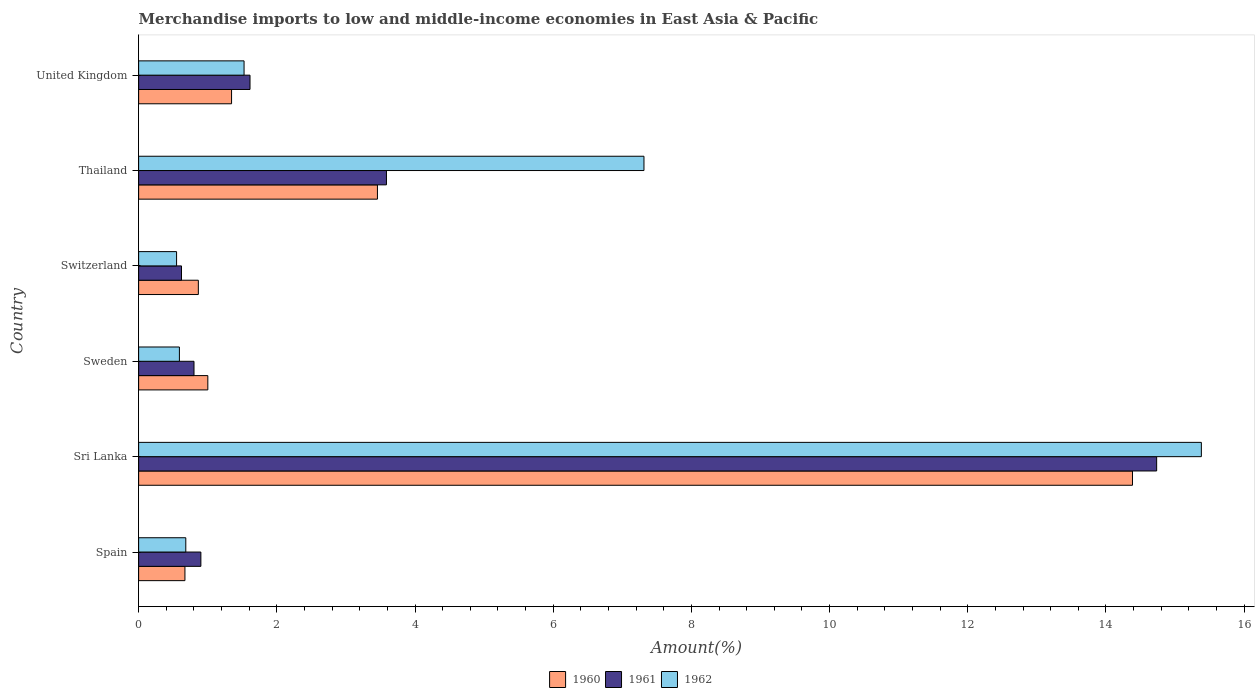Are the number of bars on each tick of the Y-axis equal?
Offer a very short reply. Yes. How many bars are there on the 2nd tick from the top?
Provide a short and direct response. 3. How many bars are there on the 3rd tick from the bottom?
Keep it short and to the point. 3. In how many cases, is the number of bars for a given country not equal to the number of legend labels?
Keep it short and to the point. 0. What is the percentage of amount earned from merchandise imports in 1960 in Thailand?
Ensure brevity in your answer.  3.46. Across all countries, what is the maximum percentage of amount earned from merchandise imports in 1961?
Keep it short and to the point. 14.73. Across all countries, what is the minimum percentage of amount earned from merchandise imports in 1960?
Your response must be concise. 0.67. In which country was the percentage of amount earned from merchandise imports in 1960 maximum?
Ensure brevity in your answer.  Sri Lanka. In which country was the percentage of amount earned from merchandise imports in 1961 minimum?
Your response must be concise. Switzerland. What is the total percentage of amount earned from merchandise imports in 1961 in the graph?
Your answer should be compact. 22.25. What is the difference between the percentage of amount earned from merchandise imports in 1962 in Sri Lanka and that in Sweden?
Your response must be concise. 14.79. What is the difference between the percentage of amount earned from merchandise imports in 1961 in United Kingdom and the percentage of amount earned from merchandise imports in 1960 in Sweden?
Your response must be concise. 0.61. What is the average percentage of amount earned from merchandise imports in 1961 per country?
Your answer should be compact. 3.71. What is the difference between the percentage of amount earned from merchandise imports in 1961 and percentage of amount earned from merchandise imports in 1962 in United Kingdom?
Your response must be concise. 0.09. In how many countries, is the percentage of amount earned from merchandise imports in 1960 greater than 1.6 %?
Your answer should be very brief. 2. What is the ratio of the percentage of amount earned from merchandise imports in 1960 in Sweden to that in Thailand?
Give a very brief answer. 0.29. What is the difference between the highest and the second highest percentage of amount earned from merchandise imports in 1962?
Make the answer very short. 8.07. What is the difference between the highest and the lowest percentage of amount earned from merchandise imports in 1961?
Offer a very short reply. 14.11. Is the sum of the percentage of amount earned from merchandise imports in 1961 in Sri Lanka and Switzerland greater than the maximum percentage of amount earned from merchandise imports in 1962 across all countries?
Your response must be concise. No. What does the 3rd bar from the bottom in Switzerland represents?
Provide a short and direct response. 1962. Is it the case that in every country, the sum of the percentage of amount earned from merchandise imports in 1961 and percentage of amount earned from merchandise imports in 1962 is greater than the percentage of amount earned from merchandise imports in 1960?
Your answer should be compact. Yes. How many bars are there?
Keep it short and to the point. 18. Does the graph contain grids?
Your answer should be very brief. No. How many legend labels are there?
Provide a short and direct response. 3. What is the title of the graph?
Provide a short and direct response. Merchandise imports to low and middle-income economies in East Asia & Pacific. What is the label or title of the X-axis?
Offer a very short reply. Amount(%). What is the Amount(%) in 1960 in Spain?
Give a very brief answer. 0.67. What is the Amount(%) in 1961 in Spain?
Keep it short and to the point. 0.9. What is the Amount(%) of 1962 in Spain?
Provide a short and direct response. 0.68. What is the Amount(%) in 1960 in Sri Lanka?
Keep it short and to the point. 14.38. What is the Amount(%) of 1961 in Sri Lanka?
Keep it short and to the point. 14.73. What is the Amount(%) in 1962 in Sri Lanka?
Give a very brief answer. 15.38. What is the Amount(%) of 1960 in Sweden?
Your answer should be compact. 1. What is the Amount(%) of 1961 in Sweden?
Offer a very short reply. 0.8. What is the Amount(%) in 1962 in Sweden?
Keep it short and to the point. 0.59. What is the Amount(%) in 1960 in Switzerland?
Keep it short and to the point. 0.86. What is the Amount(%) of 1961 in Switzerland?
Keep it short and to the point. 0.62. What is the Amount(%) of 1962 in Switzerland?
Offer a very short reply. 0.55. What is the Amount(%) of 1960 in Thailand?
Your answer should be compact. 3.46. What is the Amount(%) in 1961 in Thailand?
Keep it short and to the point. 3.59. What is the Amount(%) in 1962 in Thailand?
Provide a succinct answer. 7.31. What is the Amount(%) of 1960 in United Kingdom?
Keep it short and to the point. 1.34. What is the Amount(%) of 1961 in United Kingdom?
Offer a very short reply. 1.61. What is the Amount(%) in 1962 in United Kingdom?
Provide a short and direct response. 1.53. Across all countries, what is the maximum Amount(%) in 1960?
Your response must be concise. 14.38. Across all countries, what is the maximum Amount(%) of 1961?
Your answer should be compact. 14.73. Across all countries, what is the maximum Amount(%) of 1962?
Your answer should be very brief. 15.38. Across all countries, what is the minimum Amount(%) of 1960?
Offer a very short reply. 0.67. Across all countries, what is the minimum Amount(%) in 1961?
Offer a very short reply. 0.62. Across all countries, what is the minimum Amount(%) in 1962?
Ensure brevity in your answer.  0.55. What is the total Amount(%) in 1960 in the graph?
Your answer should be compact. 21.72. What is the total Amount(%) in 1961 in the graph?
Make the answer very short. 22.25. What is the total Amount(%) of 1962 in the graph?
Make the answer very short. 26.04. What is the difference between the Amount(%) of 1960 in Spain and that in Sri Lanka?
Provide a succinct answer. -13.71. What is the difference between the Amount(%) of 1961 in Spain and that in Sri Lanka?
Provide a short and direct response. -13.83. What is the difference between the Amount(%) in 1962 in Spain and that in Sri Lanka?
Your answer should be compact. -14.7. What is the difference between the Amount(%) of 1960 in Spain and that in Sweden?
Your answer should be compact. -0.33. What is the difference between the Amount(%) of 1961 in Spain and that in Sweden?
Your answer should be compact. 0.1. What is the difference between the Amount(%) in 1962 in Spain and that in Sweden?
Offer a terse response. 0.09. What is the difference between the Amount(%) in 1960 in Spain and that in Switzerland?
Give a very brief answer. -0.19. What is the difference between the Amount(%) in 1961 in Spain and that in Switzerland?
Your response must be concise. 0.28. What is the difference between the Amount(%) in 1962 in Spain and that in Switzerland?
Ensure brevity in your answer.  0.13. What is the difference between the Amount(%) in 1960 in Spain and that in Thailand?
Keep it short and to the point. -2.79. What is the difference between the Amount(%) of 1961 in Spain and that in Thailand?
Your answer should be very brief. -2.69. What is the difference between the Amount(%) of 1962 in Spain and that in Thailand?
Offer a very short reply. -6.63. What is the difference between the Amount(%) of 1960 in Spain and that in United Kingdom?
Your answer should be compact. -0.67. What is the difference between the Amount(%) in 1961 in Spain and that in United Kingdom?
Offer a terse response. -0.71. What is the difference between the Amount(%) of 1962 in Spain and that in United Kingdom?
Provide a succinct answer. -0.84. What is the difference between the Amount(%) in 1960 in Sri Lanka and that in Sweden?
Keep it short and to the point. 13.38. What is the difference between the Amount(%) of 1961 in Sri Lanka and that in Sweden?
Your answer should be compact. 13.93. What is the difference between the Amount(%) in 1962 in Sri Lanka and that in Sweden?
Provide a succinct answer. 14.79. What is the difference between the Amount(%) in 1960 in Sri Lanka and that in Switzerland?
Offer a very short reply. 13.52. What is the difference between the Amount(%) in 1961 in Sri Lanka and that in Switzerland?
Provide a short and direct response. 14.11. What is the difference between the Amount(%) of 1962 in Sri Lanka and that in Switzerland?
Your answer should be very brief. 14.83. What is the difference between the Amount(%) of 1960 in Sri Lanka and that in Thailand?
Offer a terse response. 10.93. What is the difference between the Amount(%) of 1961 in Sri Lanka and that in Thailand?
Offer a very short reply. 11.15. What is the difference between the Amount(%) in 1962 in Sri Lanka and that in Thailand?
Your answer should be compact. 8.07. What is the difference between the Amount(%) of 1960 in Sri Lanka and that in United Kingdom?
Give a very brief answer. 13.04. What is the difference between the Amount(%) of 1961 in Sri Lanka and that in United Kingdom?
Your answer should be compact. 13.12. What is the difference between the Amount(%) in 1962 in Sri Lanka and that in United Kingdom?
Offer a very short reply. 13.85. What is the difference between the Amount(%) in 1960 in Sweden and that in Switzerland?
Your response must be concise. 0.14. What is the difference between the Amount(%) of 1961 in Sweden and that in Switzerland?
Your response must be concise. 0.18. What is the difference between the Amount(%) of 1962 in Sweden and that in Switzerland?
Your answer should be very brief. 0.04. What is the difference between the Amount(%) of 1960 in Sweden and that in Thailand?
Make the answer very short. -2.45. What is the difference between the Amount(%) in 1961 in Sweden and that in Thailand?
Offer a terse response. -2.79. What is the difference between the Amount(%) of 1962 in Sweden and that in Thailand?
Make the answer very short. -6.72. What is the difference between the Amount(%) of 1960 in Sweden and that in United Kingdom?
Ensure brevity in your answer.  -0.34. What is the difference between the Amount(%) in 1961 in Sweden and that in United Kingdom?
Give a very brief answer. -0.81. What is the difference between the Amount(%) of 1962 in Sweden and that in United Kingdom?
Your response must be concise. -0.94. What is the difference between the Amount(%) in 1960 in Switzerland and that in Thailand?
Give a very brief answer. -2.59. What is the difference between the Amount(%) of 1961 in Switzerland and that in Thailand?
Ensure brevity in your answer.  -2.97. What is the difference between the Amount(%) of 1962 in Switzerland and that in Thailand?
Make the answer very short. -6.76. What is the difference between the Amount(%) in 1960 in Switzerland and that in United Kingdom?
Offer a very short reply. -0.48. What is the difference between the Amount(%) of 1961 in Switzerland and that in United Kingdom?
Provide a short and direct response. -0.99. What is the difference between the Amount(%) of 1962 in Switzerland and that in United Kingdom?
Provide a succinct answer. -0.98. What is the difference between the Amount(%) in 1960 in Thailand and that in United Kingdom?
Keep it short and to the point. 2.11. What is the difference between the Amount(%) of 1961 in Thailand and that in United Kingdom?
Provide a short and direct response. 1.97. What is the difference between the Amount(%) in 1962 in Thailand and that in United Kingdom?
Keep it short and to the point. 5.79. What is the difference between the Amount(%) of 1960 in Spain and the Amount(%) of 1961 in Sri Lanka?
Provide a short and direct response. -14.06. What is the difference between the Amount(%) in 1960 in Spain and the Amount(%) in 1962 in Sri Lanka?
Keep it short and to the point. -14.71. What is the difference between the Amount(%) of 1961 in Spain and the Amount(%) of 1962 in Sri Lanka?
Your answer should be very brief. -14.48. What is the difference between the Amount(%) in 1960 in Spain and the Amount(%) in 1961 in Sweden?
Your answer should be very brief. -0.13. What is the difference between the Amount(%) in 1960 in Spain and the Amount(%) in 1962 in Sweden?
Your answer should be very brief. 0.08. What is the difference between the Amount(%) in 1961 in Spain and the Amount(%) in 1962 in Sweden?
Keep it short and to the point. 0.31. What is the difference between the Amount(%) of 1960 in Spain and the Amount(%) of 1961 in Switzerland?
Provide a short and direct response. 0.05. What is the difference between the Amount(%) of 1960 in Spain and the Amount(%) of 1962 in Switzerland?
Keep it short and to the point. 0.12. What is the difference between the Amount(%) of 1961 in Spain and the Amount(%) of 1962 in Switzerland?
Give a very brief answer. 0.35. What is the difference between the Amount(%) of 1960 in Spain and the Amount(%) of 1961 in Thailand?
Your response must be concise. -2.92. What is the difference between the Amount(%) of 1960 in Spain and the Amount(%) of 1962 in Thailand?
Keep it short and to the point. -6.64. What is the difference between the Amount(%) in 1961 in Spain and the Amount(%) in 1962 in Thailand?
Your answer should be compact. -6.41. What is the difference between the Amount(%) in 1960 in Spain and the Amount(%) in 1961 in United Kingdom?
Provide a short and direct response. -0.94. What is the difference between the Amount(%) in 1960 in Spain and the Amount(%) in 1962 in United Kingdom?
Offer a terse response. -0.86. What is the difference between the Amount(%) in 1961 in Spain and the Amount(%) in 1962 in United Kingdom?
Ensure brevity in your answer.  -0.63. What is the difference between the Amount(%) in 1960 in Sri Lanka and the Amount(%) in 1961 in Sweden?
Keep it short and to the point. 13.58. What is the difference between the Amount(%) in 1960 in Sri Lanka and the Amount(%) in 1962 in Sweden?
Give a very brief answer. 13.79. What is the difference between the Amount(%) in 1961 in Sri Lanka and the Amount(%) in 1962 in Sweden?
Keep it short and to the point. 14.14. What is the difference between the Amount(%) of 1960 in Sri Lanka and the Amount(%) of 1961 in Switzerland?
Provide a succinct answer. 13.76. What is the difference between the Amount(%) in 1960 in Sri Lanka and the Amount(%) in 1962 in Switzerland?
Your response must be concise. 13.83. What is the difference between the Amount(%) in 1961 in Sri Lanka and the Amount(%) in 1962 in Switzerland?
Your response must be concise. 14.18. What is the difference between the Amount(%) in 1960 in Sri Lanka and the Amount(%) in 1961 in Thailand?
Make the answer very short. 10.8. What is the difference between the Amount(%) in 1960 in Sri Lanka and the Amount(%) in 1962 in Thailand?
Keep it short and to the point. 7.07. What is the difference between the Amount(%) in 1961 in Sri Lanka and the Amount(%) in 1962 in Thailand?
Ensure brevity in your answer.  7.42. What is the difference between the Amount(%) in 1960 in Sri Lanka and the Amount(%) in 1961 in United Kingdom?
Offer a terse response. 12.77. What is the difference between the Amount(%) of 1960 in Sri Lanka and the Amount(%) of 1962 in United Kingdom?
Your answer should be very brief. 12.86. What is the difference between the Amount(%) in 1961 in Sri Lanka and the Amount(%) in 1962 in United Kingdom?
Provide a succinct answer. 13.21. What is the difference between the Amount(%) in 1960 in Sweden and the Amount(%) in 1961 in Switzerland?
Your answer should be compact. 0.38. What is the difference between the Amount(%) in 1960 in Sweden and the Amount(%) in 1962 in Switzerland?
Make the answer very short. 0.45. What is the difference between the Amount(%) in 1961 in Sweden and the Amount(%) in 1962 in Switzerland?
Your response must be concise. 0.25. What is the difference between the Amount(%) of 1960 in Sweden and the Amount(%) of 1961 in Thailand?
Make the answer very short. -2.59. What is the difference between the Amount(%) of 1960 in Sweden and the Amount(%) of 1962 in Thailand?
Keep it short and to the point. -6.31. What is the difference between the Amount(%) in 1961 in Sweden and the Amount(%) in 1962 in Thailand?
Your answer should be compact. -6.51. What is the difference between the Amount(%) of 1960 in Sweden and the Amount(%) of 1961 in United Kingdom?
Offer a very short reply. -0.61. What is the difference between the Amount(%) of 1960 in Sweden and the Amount(%) of 1962 in United Kingdom?
Give a very brief answer. -0.52. What is the difference between the Amount(%) in 1961 in Sweden and the Amount(%) in 1962 in United Kingdom?
Your response must be concise. -0.72. What is the difference between the Amount(%) of 1960 in Switzerland and the Amount(%) of 1961 in Thailand?
Provide a succinct answer. -2.72. What is the difference between the Amount(%) of 1960 in Switzerland and the Amount(%) of 1962 in Thailand?
Offer a terse response. -6.45. What is the difference between the Amount(%) in 1961 in Switzerland and the Amount(%) in 1962 in Thailand?
Your answer should be compact. -6.69. What is the difference between the Amount(%) of 1960 in Switzerland and the Amount(%) of 1961 in United Kingdom?
Offer a terse response. -0.75. What is the difference between the Amount(%) of 1960 in Switzerland and the Amount(%) of 1962 in United Kingdom?
Your answer should be compact. -0.66. What is the difference between the Amount(%) in 1961 in Switzerland and the Amount(%) in 1962 in United Kingdom?
Make the answer very short. -0.91. What is the difference between the Amount(%) of 1960 in Thailand and the Amount(%) of 1961 in United Kingdom?
Offer a very short reply. 1.84. What is the difference between the Amount(%) of 1960 in Thailand and the Amount(%) of 1962 in United Kingdom?
Offer a very short reply. 1.93. What is the difference between the Amount(%) of 1961 in Thailand and the Amount(%) of 1962 in United Kingdom?
Offer a very short reply. 2.06. What is the average Amount(%) of 1960 per country?
Offer a very short reply. 3.62. What is the average Amount(%) in 1961 per country?
Give a very brief answer. 3.71. What is the average Amount(%) of 1962 per country?
Make the answer very short. 4.34. What is the difference between the Amount(%) of 1960 and Amount(%) of 1961 in Spain?
Offer a very short reply. -0.23. What is the difference between the Amount(%) of 1960 and Amount(%) of 1962 in Spain?
Offer a terse response. -0.01. What is the difference between the Amount(%) in 1961 and Amount(%) in 1962 in Spain?
Ensure brevity in your answer.  0.22. What is the difference between the Amount(%) in 1960 and Amount(%) in 1961 in Sri Lanka?
Keep it short and to the point. -0.35. What is the difference between the Amount(%) in 1960 and Amount(%) in 1962 in Sri Lanka?
Your answer should be compact. -1. What is the difference between the Amount(%) of 1961 and Amount(%) of 1962 in Sri Lanka?
Offer a very short reply. -0.65. What is the difference between the Amount(%) of 1960 and Amount(%) of 1961 in Sweden?
Provide a short and direct response. 0.2. What is the difference between the Amount(%) of 1960 and Amount(%) of 1962 in Sweden?
Give a very brief answer. 0.41. What is the difference between the Amount(%) of 1961 and Amount(%) of 1962 in Sweden?
Make the answer very short. 0.21. What is the difference between the Amount(%) of 1960 and Amount(%) of 1961 in Switzerland?
Your response must be concise. 0.24. What is the difference between the Amount(%) in 1960 and Amount(%) in 1962 in Switzerland?
Your response must be concise. 0.31. What is the difference between the Amount(%) of 1961 and Amount(%) of 1962 in Switzerland?
Make the answer very short. 0.07. What is the difference between the Amount(%) in 1960 and Amount(%) in 1961 in Thailand?
Your answer should be very brief. -0.13. What is the difference between the Amount(%) in 1960 and Amount(%) in 1962 in Thailand?
Keep it short and to the point. -3.86. What is the difference between the Amount(%) of 1961 and Amount(%) of 1962 in Thailand?
Your response must be concise. -3.73. What is the difference between the Amount(%) in 1960 and Amount(%) in 1961 in United Kingdom?
Your answer should be compact. -0.27. What is the difference between the Amount(%) of 1960 and Amount(%) of 1962 in United Kingdom?
Ensure brevity in your answer.  -0.18. What is the difference between the Amount(%) in 1961 and Amount(%) in 1962 in United Kingdom?
Ensure brevity in your answer.  0.09. What is the ratio of the Amount(%) of 1960 in Spain to that in Sri Lanka?
Your response must be concise. 0.05. What is the ratio of the Amount(%) in 1961 in Spain to that in Sri Lanka?
Keep it short and to the point. 0.06. What is the ratio of the Amount(%) of 1962 in Spain to that in Sri Lanka?
Keep it short and to the point. 0.04. What is the ratio of the Amount(%) of 1960 in Spain to that in Sweden?
Ensure brevity in your answer.  0.67. What is the ratio of the Amount(%) in 1961 in Spain to that in Sweden?
Offer a terse response. 1.12. What is the ratio of the Amount(%) in 1962 in Spain to that in Sweden?
Ensure brevity in your answer.  1.16. What is the ratio of the Amount(%) in 1960 in Spain to that in Switzerland?
Give a very brief answer. 0.78. What is the ratio of the Amount(%) of 1961 in Spain to that in Switzerland?
Your response must be concise. 1.45. What is the ratio of the Amount(%) of 1962 in Spain to that in Switzerland?
Your answer should be very brief. 1.24. What is the ratio of the Amount(%) of 1960 in Spain to that in Thailand?
Ensure brevity in your answer.  0.19. What is the ratio of the Amount(%) in 1961 in Spain to that in Thailand?
Your answer should be very brief. 0.25. What is the ratio of the Amount(%) of 1962 in Spain to that in Thailand?
Make the answer very short. 0.09. What is the ratio of the Amount(%) in 1960 in Spain to that in United Kingdom?
Provide a succinct answer. 0.5. What is the ratio of the Amount(%) of 1961 in Spain to that in United Kingdom?
Offer a terse response. 0.56. What is the ratio of the Amount(%) in 1962 in Spain to that in United Kingdom?
Your response must be concise. 0.45. What is the ratio of the Amount(%) of 1960 in Sri Lanka to that in Sweden?
Your answer should be very brief. 14.36. What is the ratio of the Amount(%) in 1961 in Sri Lanka to that in Sweden?
Provide a short and direct response. 18.38. What is the ratio of the Amount(%) of 1962 in Sri Lanka to that in Sweden?
Provide a short and direct response. 26.07. What is the ratio of the Amount(%) of 1960 in Sri Lanka to that in Switzerland?
Offer a very short reply. 16.64. What is the ratio of the Amount(%) in 1961 in Sri Lanka to that in Switzerland?
Ensure brevity in your answer.  23.74. What is the ratio of the Amount(%) in 1962 in Sri Lanka to that in Switzerland?
Provide a short and direct response. 28. What is the ratio of the Amount(%) in 1960 in Sri Lanka to that in Thailand?
Ensure brevity in your answer.  4.16. What is the ratio of the Amount(%) of 1961 in Sri Lanka to that in Thailand?
Offer a terse response. 4.11. What is the ratio of the Amount(%) of 1962 in Sri Lanka to that in Thailand?
Offer a very short reply. 2.1. What is the ratio of the Amount(%) of 1960 in Sri Lanka to that in United Kingdom?
Provide a short and direct response. 10.69. What is the ratio of the Amount(%) of 1961 in Sri Lanka to that in United Kingdom?
Your response must be concise. 9.14. What is the ratio of the Amount(%) of 1962 in Sri Lanka to that in United Kingdom?
Make the answer very short. 10.08. What is the ratio of the Amount(%) in 1960 in Sweden to that in Switzerland?
Give a very brief answer. 1.16. What is the ratio of the Amount(%) in 1961 in Sweden to that in Switzerland?
Provide a short and direct response. 1.29. What is the ratio of the Amount(%) in 1962 in Sweden to that in Switzerland?
Offer a terse response. 1.07. What is the ratio of the Amount(%) of 1960 in Sweden to that in Thailand?
Your response must be concise. 0.29. What is the ratio of the Amount(%) of 1961 in Sweden to that in Thailand?
Make the answer very short. 0.22. What is the ratio of the Amount(%) in 1962 in Sweden to that in Thailand?
Make the answer very short. 0.08. What is the ratio of the Amount(%) of 1960 in Sweden to that in United Kingdom?
Keep it short and to the point. 0.74. What is the ratio of the Amount(%) of 1961 in Sweden to that in United Kingdom?
Offer a very short reply. 0.5. What is the ratio of the Amount(%) in 1962 in Sweden to that in United Kingdom?
Offer a terse response. 0.39. What is the ratio of the Amount(%) in 1961 in Switzerland to that in Thailand?
Ensure brevity in your answer.  0.17. What is the ratio of the Amount(%) in 1962 in Switzerland to that in Thailand?
Your answer should be compact. 0.08. What is the ratio of the Amount(%) in 1960 in Switzerland to that in United Kingdom?
Give a very brief answer. 0.64. What is the ratio of the Amount(%) in 1961 in Switzerland to that in United Kingdom?
Provide a short and direct response. 0.39. What is the ratio of the Amount(%) of 1962 in Switzerland to that in United Kingdom?
Ensure brevity in your answer.  0.36. What is the ratio of the Amount(%) in 1960 in Thailand to that in United Kingdom?
Give a very brief answer. 2.57. What is the ratio of the Amount(%) in 1961 in Thailand to that in United Kingdom?
Offer a terse response. 2.23. What is the ratio of the Amount(%) of 1962 in Thailand to that in United Kingdom?
Offer a terse response. 4.79. What is the difference between the highest and the second highest Amount(%) of 1960?
Give a very brief answer. 10.93. What is the difference between the highest and the second highest Amount(%) in 1961?
Your response must be concise. 11.15. What is the difference between the highest and the second highest Amount(%) in 1962?
Provide a short and direct response. 8.07. What is the difference between the highest and the lowest Amount(%) in 1960?
Your response must be concise. 13.71. What is the difference between the highest and the lowest Amount(%) of 1961?
Make the answer very short. 14.11. What is the difference between the highest and the lowest Amount(%) of 1962?
Your response must be concise. 14.83. 